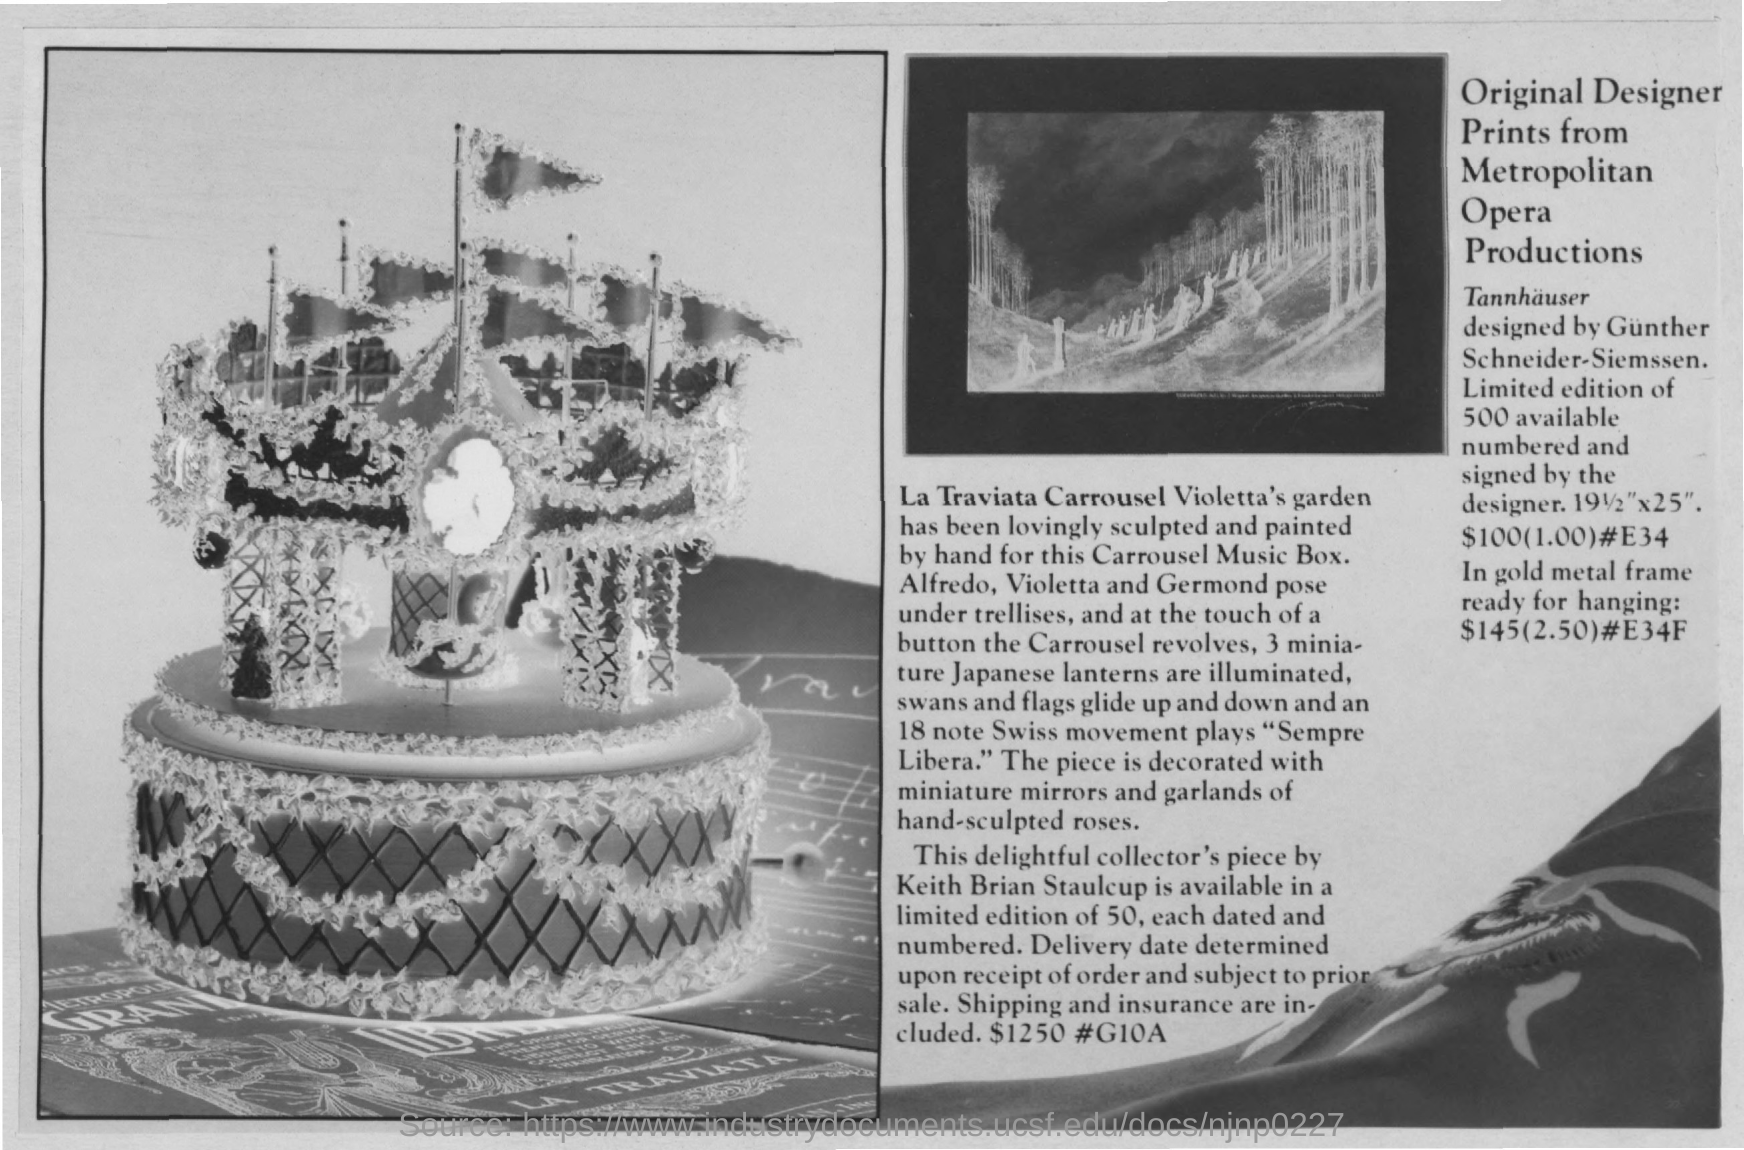Whats sculpted and painted on the music box?
Ensure brevity in your answer.  Violetta's Garden. Who designed Tannhauser?
Provide a succinct answer. Gunther Schneider-Siemssen. How many pieces of Original Designer Print from Metropolitan Opera Production  were available?
Offer a very short reply. 500. 